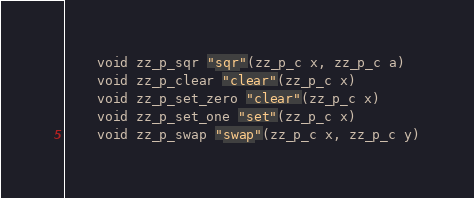Convert code to text. <code><loc_0><loc_0><loc_500><loc_500><_Cython_>    void zz_p_sqr "sqr"(zz_p_c x, zz_p_c a)
    void zz_p_clear "clear"(zz_p_c x)
    void zz_p_set_zero "clear"(zz_p_c x)
    void zz_p_set_one "set"(zz_p_c x)
    void zz_p_swap "swap"(zz_p_c x, zz_p_c y)
</code> 